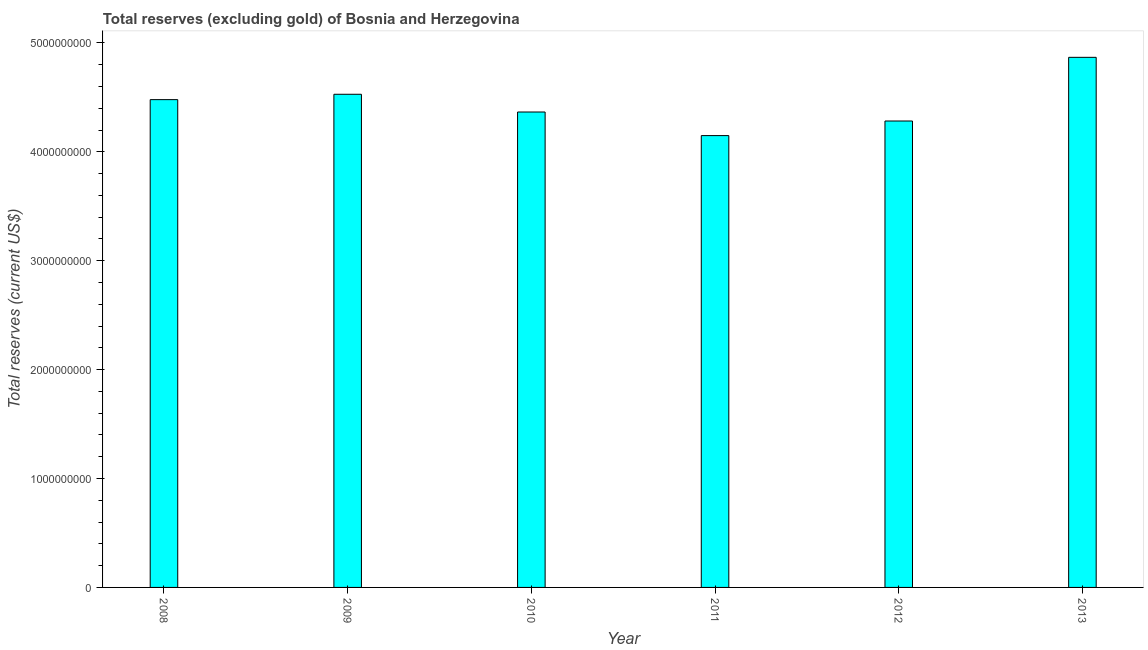Does the graph contain grids?
Make the answer very short. No. What is the title of the graph?
Offer a terse response. Total reserves (excluding gold) of Bosnia and Herzegovina. What is the label or title of the Y-axis?
Keep it short and to the point. Total reserves (current US$). What is the total reserves (excluding gold) in 2008?
Your response must be concise. 4.48e+09. Across all years, what is the maximum total reserves (excluding gold)?
Your response must be concise. 4.87e+09. Across all years, what is the minimum total reserves (excluding gold)?
Offer a terse response. 4.15e+09. In which year was the total reserves (excluding gold) maximum?
Your answer should be compact. 2013. In which year was the total reserves (excluding gold) minimum?
Your response must be concise. 2011. What is the sum of the total reserves (excluding gold)?
Provide a short and direct response. 2.67e+1. What is the difference between the total reserves (excluding gold) in 2010 and 2012?
Offer a terse response. 8.27e+07. What is the average total reserves (excluding gold) per year?
Ensure brevity in your answer.  4.45e+09. What is the median total reserves (excluding gold)?
Your answer should be very brief. 4.42e+09. What is the ratio of the total reserves (excluding gold) in 2008 to that in 2012?
Offer a very short reply. 1.05. Is the difference between the total reserves (excluding gold) in 2011 and 2013 greater than the difference between any two years?
Your response must be concise. Yes. What is the difference between the highest and the second highest total reserves (excluding gold)?
Make the answer very short. 3.39e+08. What is the difference between the highest and the lowest total reserves (excluding gold)?
Keep it short and to the point. 7.19e+08. How many years are there in the graph?
Keep it short and to the point. 6. What is the difference between two consecutive major ticks on the Y-axis?
Provide a short and direct response. 1.00e+09. What is the Total reserves (current US$) in 2008?
Give a very brief answer. 4.48e+09. What is the Total reserves (current US$) in 2009?
Your answer should be very brief. 4.53e+09. What is the Total reserves (current US$) in 2010?
Keep it short and to the point. 4.37e+09. What is the Total reserves (current US$) in 2011?
Your answer should be compact. 4.15e+09. What is the Total reserves (current US$) in 2012?
Provide a short and direct response. 4.28e+09. What is the Total reserves (current US$) of 2013?
Your answer should be compact. 4.87e+09. What is the difference between the Total reserves (current US$) in 2008 and 2009?
Provide a short and direct response. -4.92e+07. What is the difference between the Total reserves (current US$) in 2008 and 2010?
Offer a terse response. 1.14e+08. What is the difference between the Total reserves (current US$) in 2008 and 2011?
Ensure brevity in your answer.  3.30e+08. What is the difference between the Total reserves (current US$) in 2008 and 2012?
Offer a terse response. 1.96e+08. What is the difference between the Total reserves (current US$) in 2008 and 2013?
Your answer should be very brief. -3.89e+08. What is the difference between the Total reserves (current US$) in 2009 and 2010?
Your answer should be compact. 1.63e+08. What is the difference between the Total reserves (current US$) in 2009 and 2011?
Keep it short and to the point. 3.79e+08. What is the difference between the Total reserves (current US$) in 2009 and 2012?
Your answer should be very brief. 2.46e+08. What is the difference between the Total reserves (current US$) in 2009 and 2013?
Provide a succinct answer. -3.39e+08. What is the difference between the Total reserves (current US$) in 2010 and 2011?
Your answer should be compact. 2.17e+08. What is the difference between the Total reserves (current US$) in 2010 and 2012?
Provide a succinct answer. 8.27e+07. What is the difference between the Total reserves (current US$) in 2010 and 2013?
Offer a terse response. -5.02e+08. What is the difference between the Total reserves (current US$) in 2011 and 2012?
Offer a very short reply. -1.34e+08. What is the difference between the Total reserves (current US$) in 2011 and 2013?
Provide a short and direct response. -7.19e+08. What is the difference between the Total reserves (current US$) in 2012 and 2013?
Offer a very short reply. -5.85e+08. What is the ratio of the Total reserves (current US$) in 2008 to that in 2009?
Give a very brief answer. 0.99. What is the ratio of the Total reserves (current US$) in 2008 to that in 2010?
Make the answer very short. 1.03. What is the ratio of the Total reserves (current US$) in 2008 to that in 2011?
Keep it short and to the point. 1.08. What is the ratio of the Total reserves (current US$) in 2008 to that in 2012?
Your answer should be compact. 1.05. What is the ratio of the Total reserves (current US$) in 2009 to that in 2010?
Ensure brevity in your answer.  1.04. What is the ratio of the Total reserves (current US$) in 2009 to that in 2011?
Offer a very short reply. 1.09. What is the ratio of the Total reserves (current US$) in 2009 to that in 2012?
Provide a succinct answer. 1.06. What is the ratio of the Total reserves (current US$) in 2010 to that in 2011?
Ensure brevity in your answer.  1.05. What is the ratio of the Total reserves (current US$) in 2010 to that in 2013?
Your answer should be compact. 0.9. What is the ratio of the Total reserves (current US$) in 2011 to that in 2012?
Your answer should be compact. 0.97. What is the ratio of the Total reserves (current US$) in 2011 to that in 2013?
Your answer should be compact. 0.85. What is the ratio of the Total reserves (current US$) in 2012 to that in 2013?
Keep it short and to the point. 0.88. 